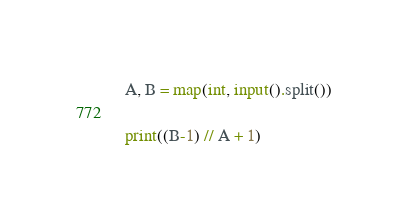Convert code to text. <code><loc_0><loc_0><loc_500><loc_500><_Python_>A, B = map(int, input().split())

print((B-1) // A + 1)</code> 